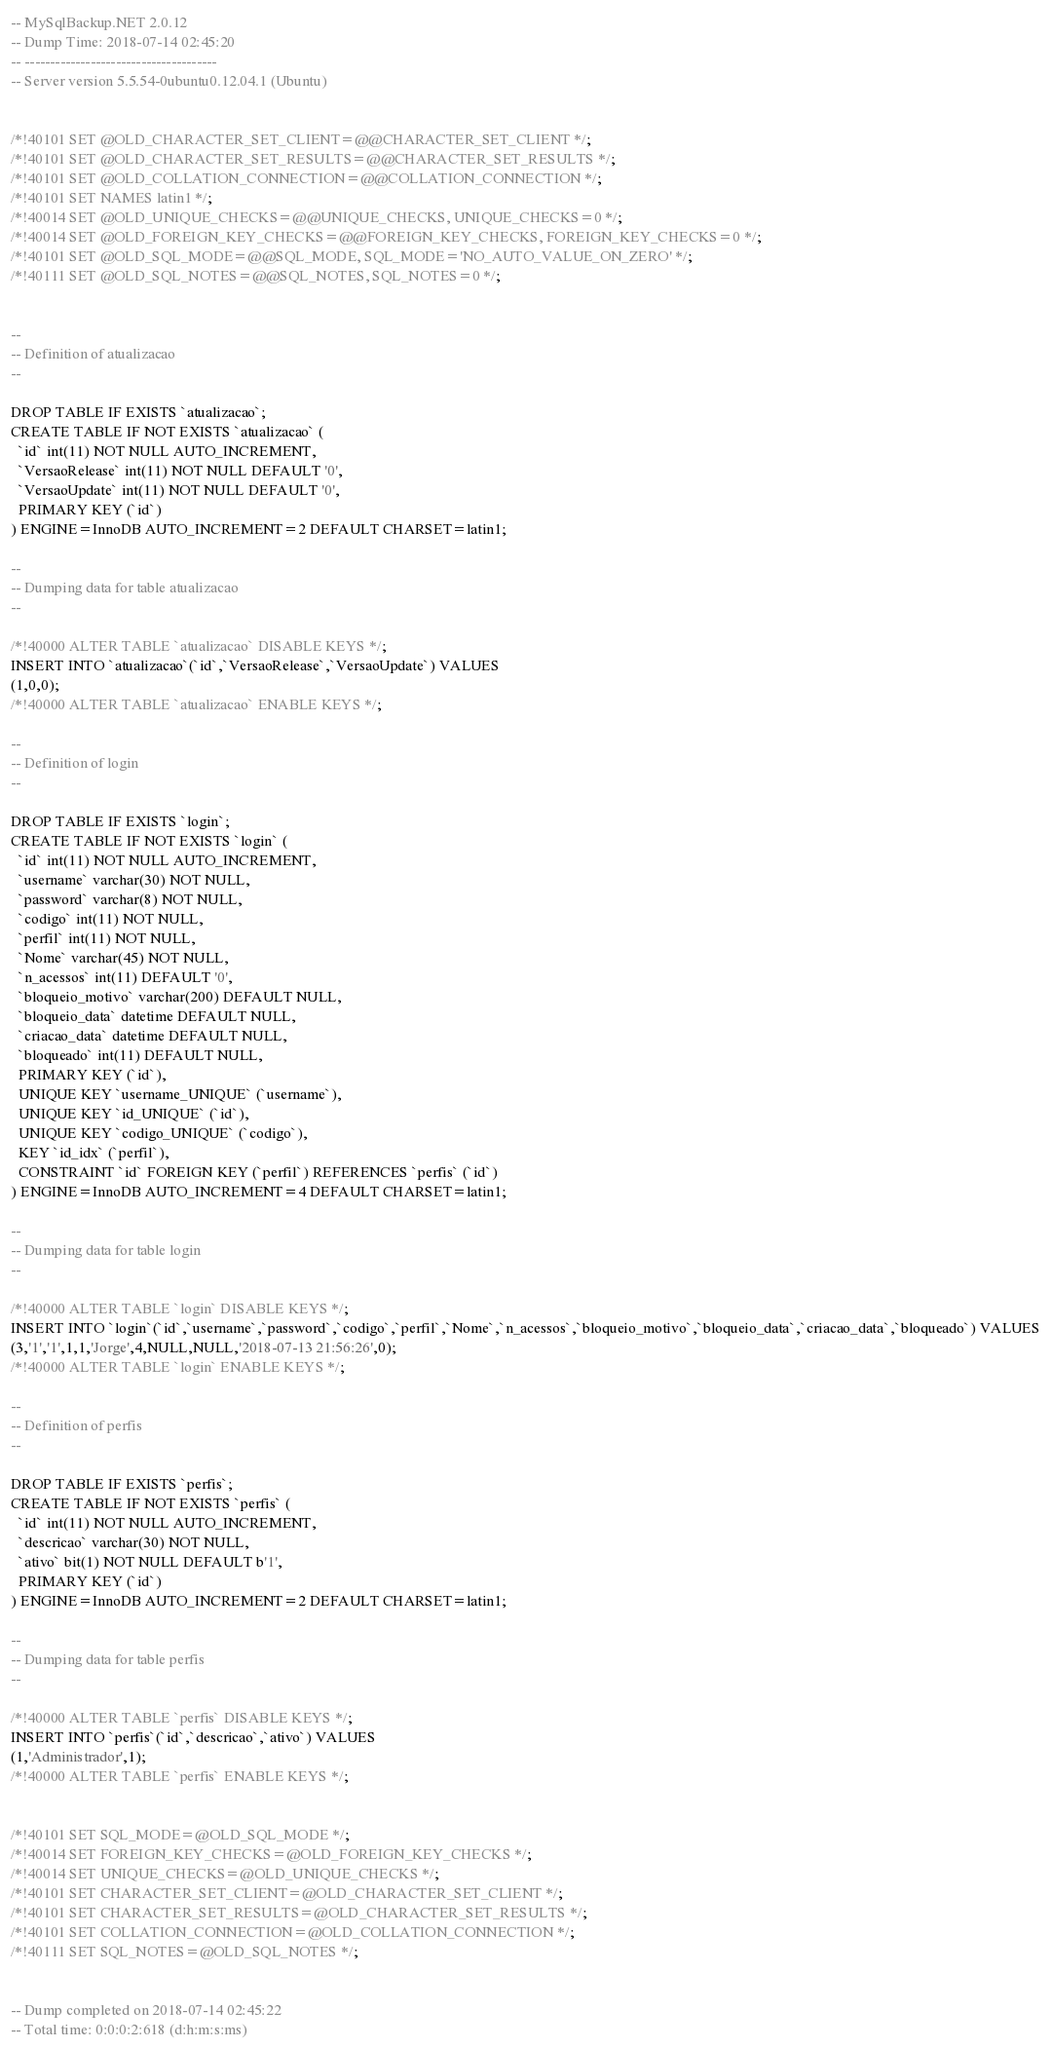<code> <loc_0><loc_0><loc_500><loc_500><_SQL_>-- MySqlBackup.NET 2.0.12
-- Dump Time: 2018-07-14 02:45:20
-- --------------------------------------
-- Server version 5.5.54-0ubuntu0.12.04.1 (Ubuntu)


/*!40101 SET @OLD_CHARACTER_SET_CLIENT=@@CHARACTER_SET_CLIENT */;
/*!40101 SET @OLD_CHARACTER_SET_RESULTS=@@CHARACTER_SET_RESULTS */;
/*!40101 SET @OLD_COLLATION_CONNECTION=@@COLLATION_CONNECTION */;
/*!40101 SET NAMES latin1 */;
/*!40014 SET @OLD_UNIQUE_CHECKS=@@UNIQUE_CHECKS, UNIQUE_CHECKS=0 */;
/*!40014 SET @OLD_FOREIGN_KEY_CHECKS=@@FOREIGN_KEY_CHECKS, FOREIGN_KEY_CHECKS=0 */;
/*!40101 SET @OLD_SQL_MODE=@@SQL_MODE, SQL_MODE='NO_AUTO_VALUE_ON_ZERO' */;
/*!40111 SET @OLD_SQL_NOTES=@@SQL_NOTES, SQL_NOTES=0 */;


-- 
-- Definition of atualizacao
-- 

DROP TABLE IF EXISTS `atualizacao`;
CREATE TABLE IF NOT EXISTS `atualizacao` (
  `id` int(11) NOT NULL AUTO_INCREMENT,
  `VersaoRelease` int(11) NOT NULL DEFAULT '0',
  `VersaoUpdate` int(11) NOT NULL DEFAULT '0',
  PRIMARY KEY (`id`)
) ENGINE=InnoDB AUTO_INCREMENT=2 DEFAULT CHARSET=latin1;

-- 
-- Dumping data for table atualizacao
-- 

/*!40000 ALTER TABLE `atualizacao` DISABLE KEYS */;
INSERT INTO `atualizacao`(`id`,`VersaoRelease`,`VersaoUpdate`) VALUES
(1,0,0);
/*!40000 ALTER TABLE `atualizacao` ENABLE KEYS */;

-- 
-- Definition of login
-- 

DROP TABLE IF EXISTS `login`;
CREATE TABLE IF NOT EXISTS `login` (
  `id` int(11) NOT NULL AUTO_INCREMENT,
  `username` varchar(30) NOT NULL,
  `password` varchar(8) NOT NULL,
  `codigo` int(11) NOT NULL,
  `perfil` int(11) NOT NULL,
  `Nome` varchar(45) NOT NULL,
  `n_acessos` int(11) DEFAULT '0',
  `bloqueio_motivo` varchar(200) DEFAULT NULL,
  `bloqueio_data` datetime DEFAULT NULL,
  `criacao_data` datetime DEFAULT NULL,
  `bloqueado` int(11) DEFAULT NULL,
  PRIMARY KEY (`id`),
  UNIQUE KEY `username_UNIQUE` (`username`),
  UNIQUE KEY `id_UNIQUE` (`id`),
  UNIQUE KEY `codigo_UNIQUE` (`codigo`),
  KEY `id_idx` (`perfil`),
  CONSTRAINT `id` FOREIGN KEY (`perfil`) REFERENCES `perfis` (`id`)
) ENGINE=InnoDB AUTO_INCREMENT=4 DEFAULT CHARSET=latin1;

-- 
-- Dumping data for table login
-- 

/*!40000 ALTER TABLE `login` DISABLE KEYS */;
INSERT INTO `login`(`id`,`username`,`password`,`codigo`,`perfil`,`Nome`,`n_acessos`,`bloqueio_motivo`,`bloqueio_data`,`criacao_data`,`bloqueado`) VALUES
(3,'1','1',1,1,'Jorge',4,NULL,NULL,'2018-07-13 21:56:26',0);
/*!40000 ALTER TABLE `login` ENABLE KEYS */;

-- 
-- Definition of perfis
-- 

DROP TABLE IF EXISTS `perfis`;
CREATE TABLE IF NOT EXISTS `perfis` (
  `id` int(11) NOT NULL AUTO_INCREMENT,
  `descricao` varchar(30) NOT NULL,
  `ativo` bit(1) NOT NULL DEFAULT b'1',
  PRIMARY KEY (`id`)
) ENGINE=InnoDB AUTO_INCREMENT=2 DEFAULT CHARSET=latin1;

-- 
-- Dumping data for table perfis
-- 

/*!40000 ALTER TABLE `perfis` DISABLE KEYS */;
INSERT INTO `perfis`(`id`,`descricao`,`ativo`) VALUES
(1,'Administrador',1);
/*!40000 ALTER TABLE `perfis` ENABLE KEYS */;


/*!40101 SET SQL_MODE=@OLD_SQL_MODE */;
/*!40014 SET FOREIGN_KEY_CHECKS=@OLD_FOREIGN_KEY_CHECKS */;
/*!40014 SET UNIQUE_CHECKS=@OLD_UNIQUE_CHECKS */;
/*!40101 SET CHARACTER_SET_CLIENT=@OLD_CHARACTER_SET_CLIENT */;
/*!40101 SET CHARACTER_SET_RESULTS=@OLD_CHARACTER_SET_RESULTS */;
/*!40101 SET COLLATION_CONNECTION=@OLD_COLLATION_CONNECTION */;
/*!40111 SET SQL_NOTES=@OLD_SQL_NOTES */;


-- Dump completed on 2018-07-14 02:45:22
-- Total time: 0:0:0:2:618 (d:h:m:s:ms)
</code> 